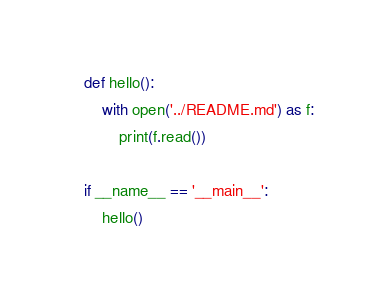Convert code to text. <code><loc_0><loc_0><loc_500><loc_500><_Python_>

def hello():
    with open('../README.md') as f:
        print(f.read())

if __name__ == '__main__':
    hello()</code> 